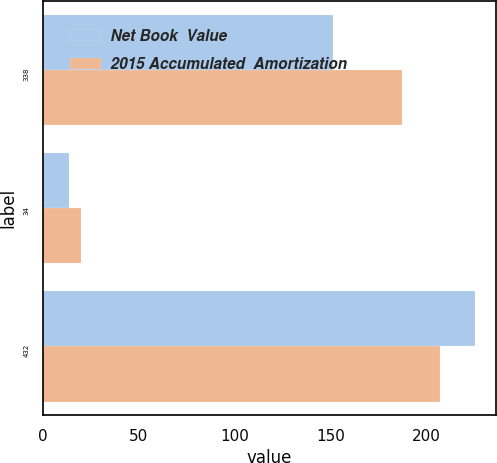<chart> <loc_0><loc_0><loc_500><loc_500><stacked_bar_chart><ecel><fcel>338<fcel>34<fcel>432<nl><fcel>Net Book  Value<fcel>151<fcel>14<fcel>225<nl><fcel>2015 Accumulated  Amortization<fcel>187<fcel>20<fcel>207<nl></chart> 